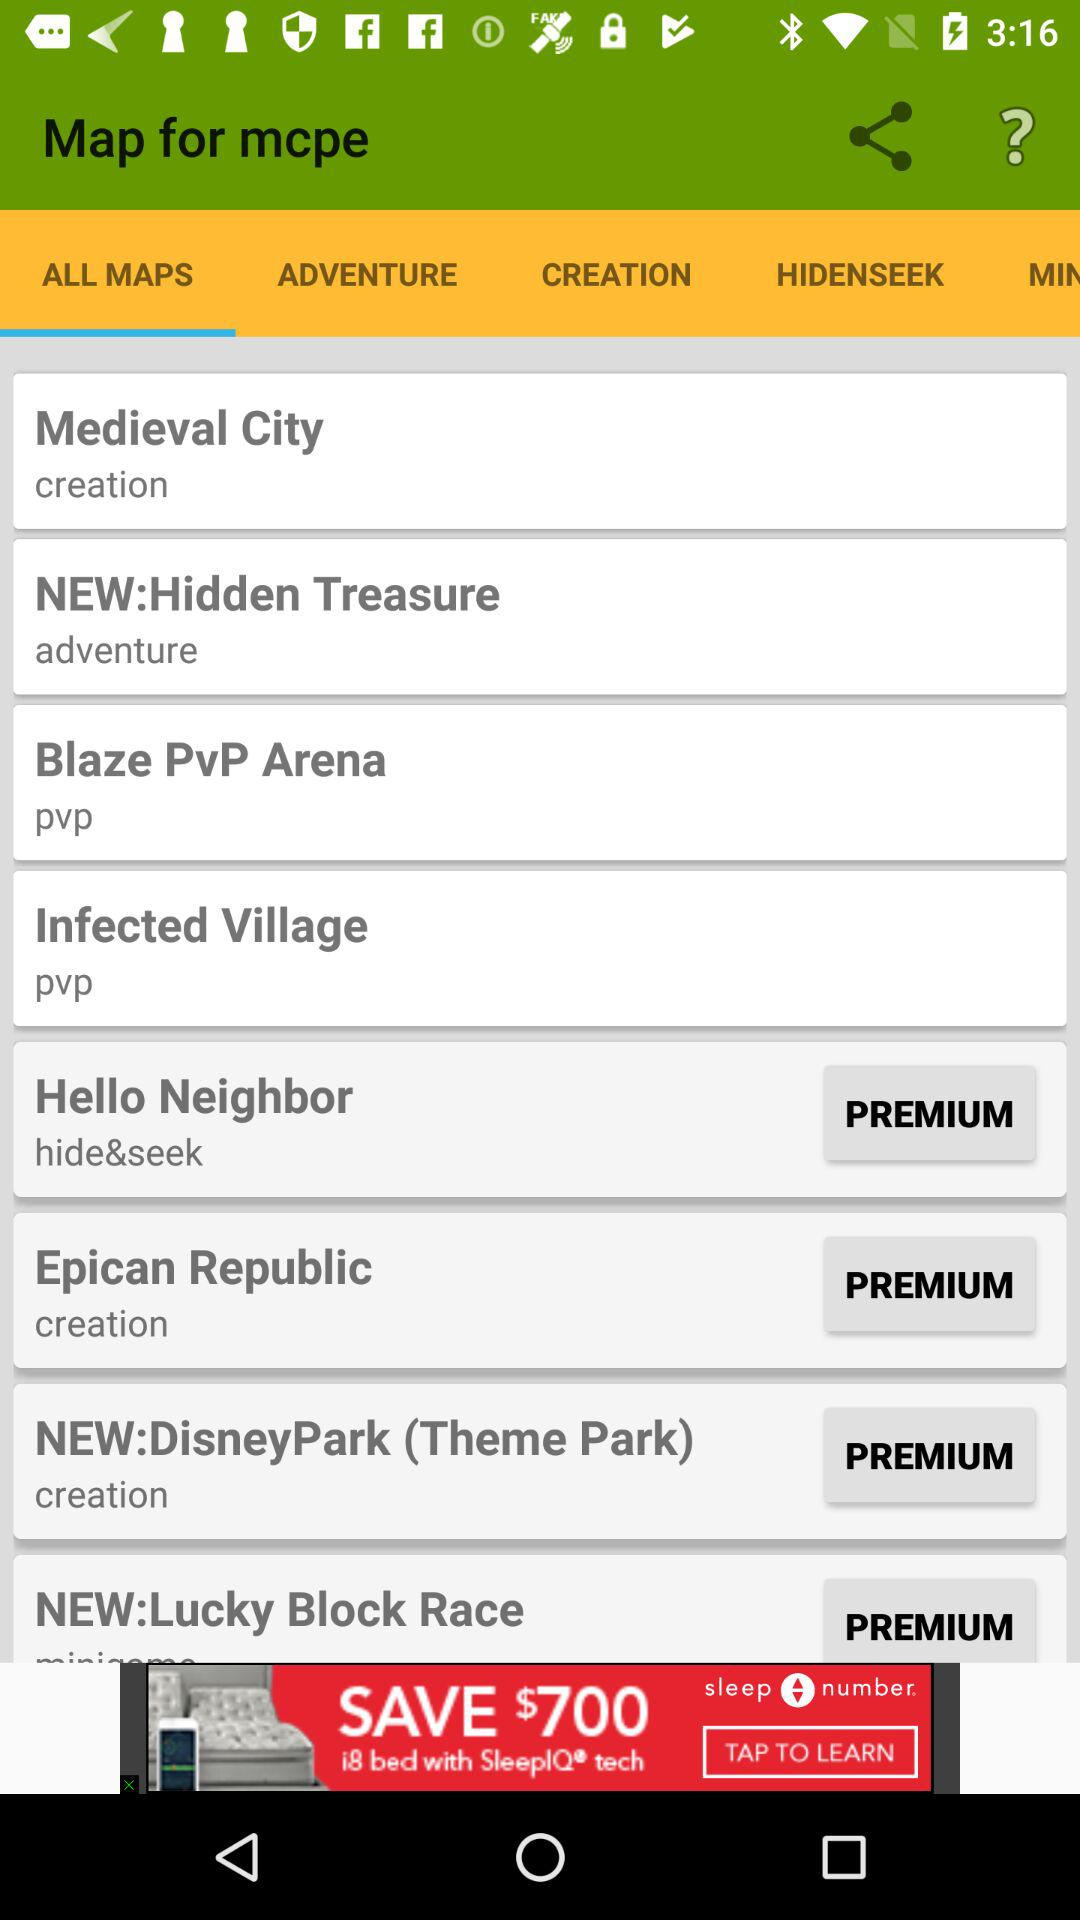What is the name of the application? The application name is "Map for mcpe". 